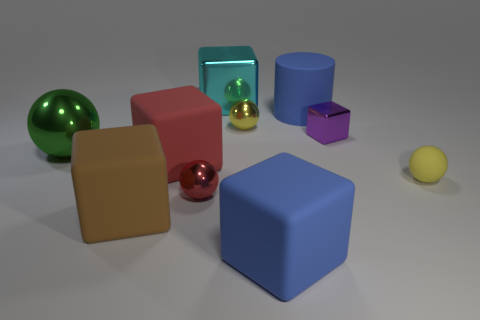Is there any other thing that is the same color as the small metal cube?
Your answer should be compact. No. Is there any other thing that is the same shape as the red rubber thing?
Your answer should be compact. Yes. What color is the big ball?
Ensure brevity in your answer.  Green. How many red metal things have the same shape as the yellow matte object?
Keep it short and to the point. 1. What color is the shiny cube that is the same size as the matte cylinder?
Your response must be concise. Cyan. Are any yellow rubber things visible?
Your response must be concise. Yes. What shape is the big blue object that is behind the red metallic sphere?
Provide a succinct answer. Cylinder. What number of large things are both in front of the red shiny sphere and right of the large red block?
Keep it short and to the point. 1. Is there a red object made of the same material as the cyan block?
Give a very brief answer. Yes. There is a block that is the same color as the cylinder; what is its size?
Make the answer very short. Large. 